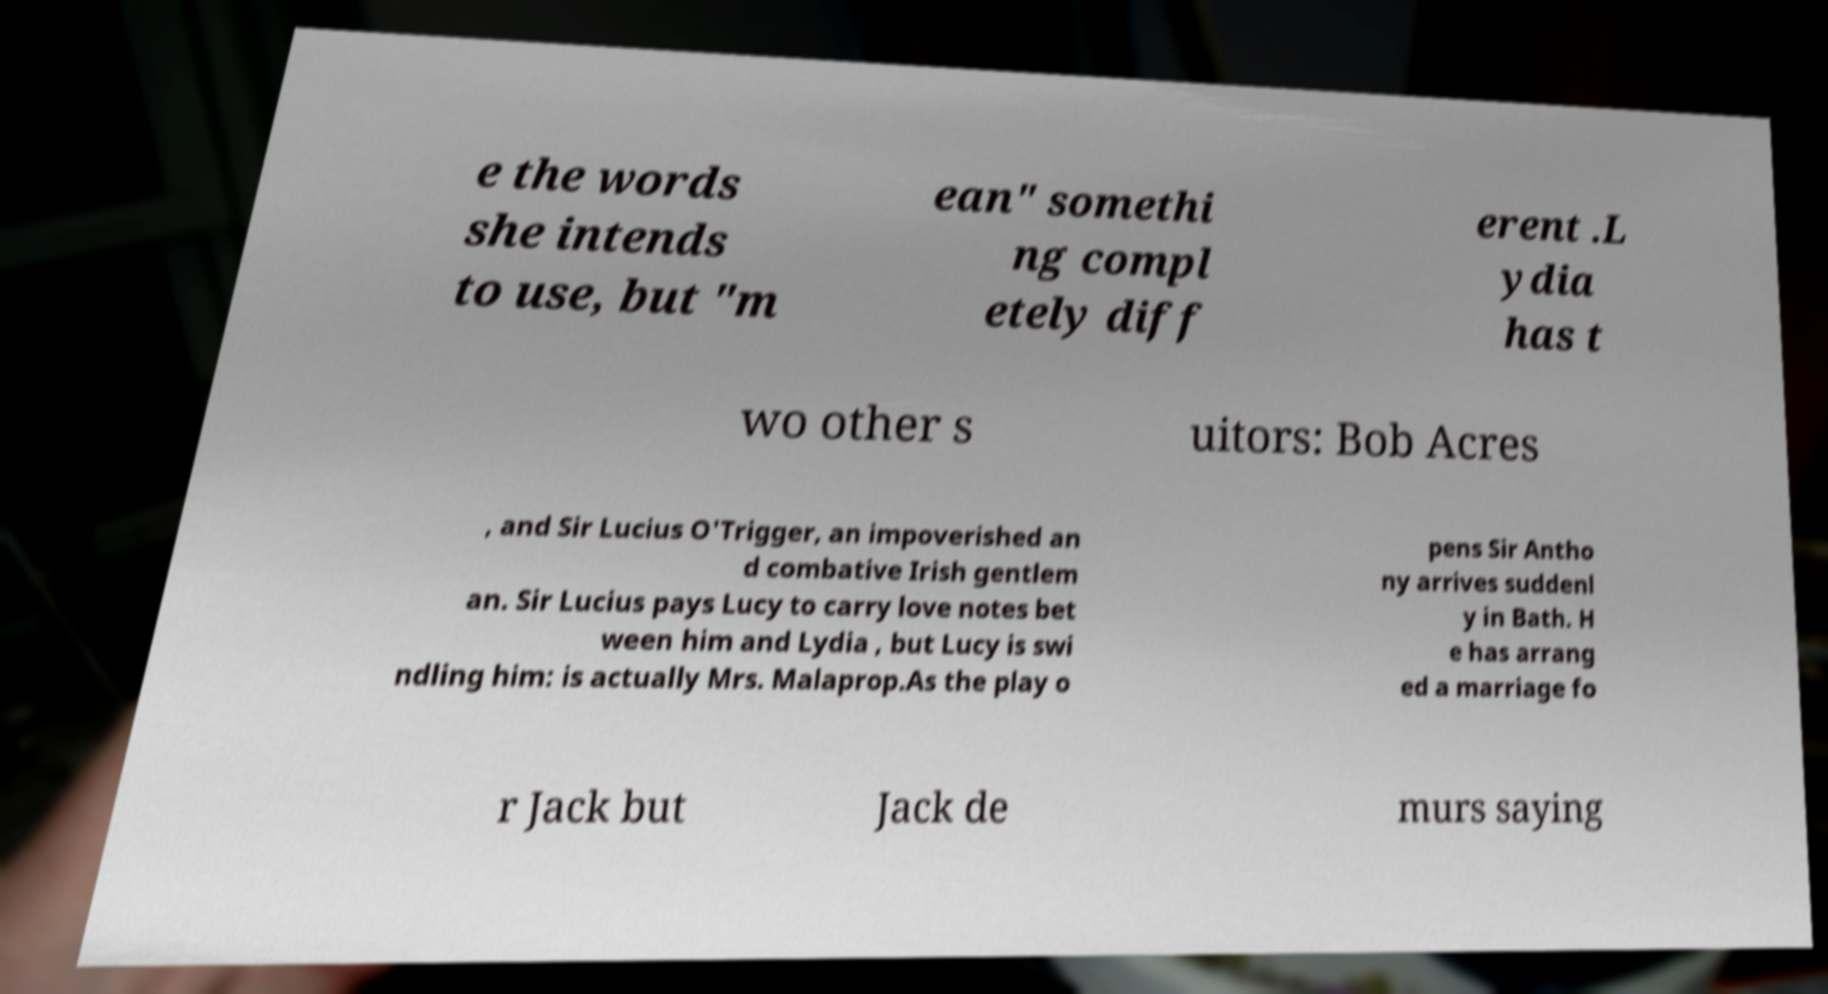What messages or text are displayed in this image? I need them in a readable, typed format. e the words she intends to use, but "m ean" somethi ng compl etely diff erent .L ydia has t wo other s uitors: Bob Acres , and Sir Lucius O'Trigger, an impoverished an d combative Irish gentlem an. Sir Lucius pays Lucy to carry love notes bet ween him and Lydia , but Lucy is swi ndling him: is actually Mrs. Malaprop.As the play o pens Sir Antho ny arrives suddenl y in Bath. H e has arrang ed a marriage fo r Jack but Jack de murs saying 